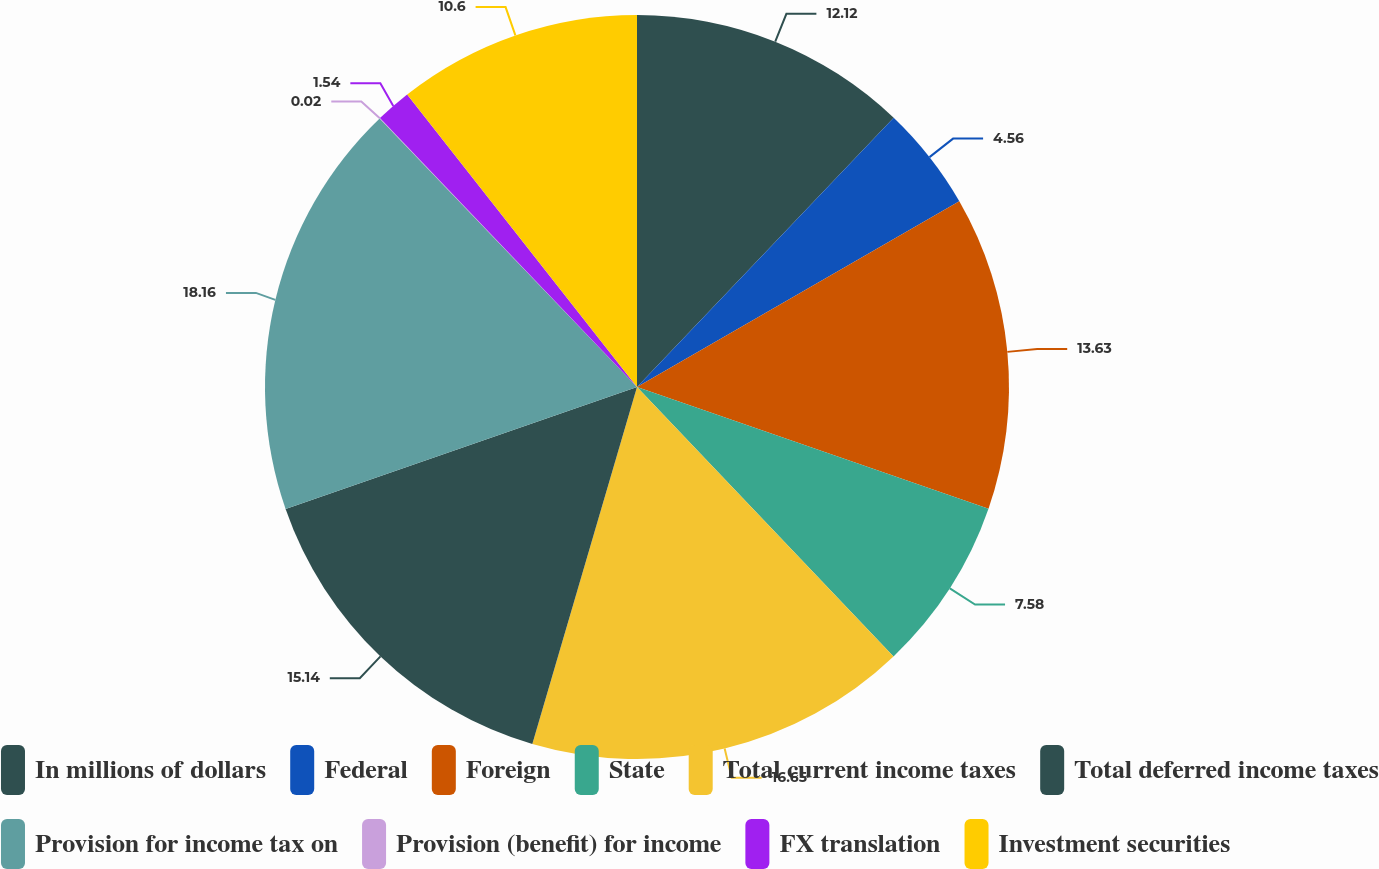Convert chart to OTSL. <chart><loc_0><loc_0><loc_500><loc_500><pie_chart><fcel>In millions of dollars<fcel>Federal<fcel>Foreign<fcel>State<fcel>Total current income taxes<fcel>Total deferred income taxes<fcel>Provision for income tax on<fcel>Provision (benefit) for income<fcel>FX translation<fcel>Investment securities<nl><fcel>12.12%<fcel>4.56%<fcel>13.63%<fcel>7.58%<fcel>16.65%<fcel>15.14%<fcel>18.16%<fcel>0.02%<fcel>1.54%<fcel>10.6%<nl></chart> 